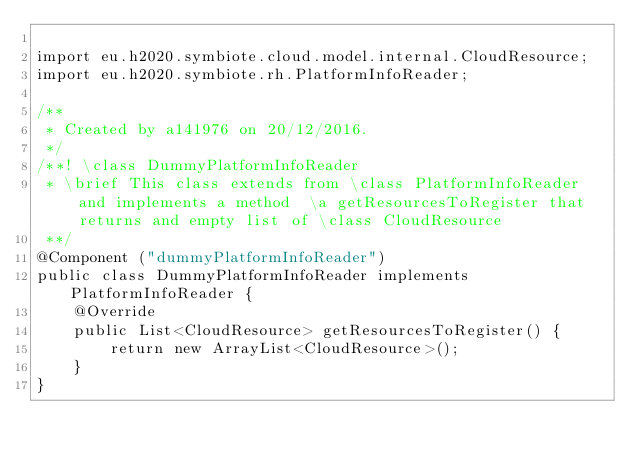Convert code to text. <code><loc_0><loc_0><loc_500><loc_500><_Java_>
import eu.h2020.symbiote.cloud.model.internal.CloudResource;
import eu.h2020.symbiote.rh.PlatformInfoReader;

/**
 * Created by a141976 on 20/12/2016.
 */
/**! \class DummyPlatformInfoReader
 * \brief This class extends from \class PlatformInfoReader and implements a method  \a getResourcesToRegister that returns and empty list of \class CloudResource
 **/
@Component ("dummyPlatformInfoReader")
public class DummyPlatformInfoReader implements PlatformInfoReader {
    @Override
    public List<CloudResource> getResourcesToRegister() {
        return new ArrayList<CloudResource>();
    }
}
</code> 